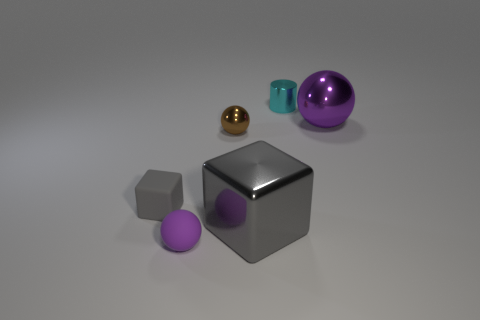Subtract all small balls. How many balls are left? 1 Add 3 large red metal blocks. How many objects exist? 9 Subtract all brown spheres. How many spheres are left? 2 Subtract 0 red balls. How many objects are left? 6 Subtract all blocks. How many objects are left? 4 Subtract 1 spheres. How many spheres are left? 2 Subtract all purple cylinders. Subtract all gray spheres. How many cylinders are left? 1 Subtract all brown blocks. How many brown balls are left? 1 Subtract all small cyan shiny objects. Subtract all cyan shiny cylinders. How many objects are left? 4 Add 2 big gray things. How many big gray things are left? 3 